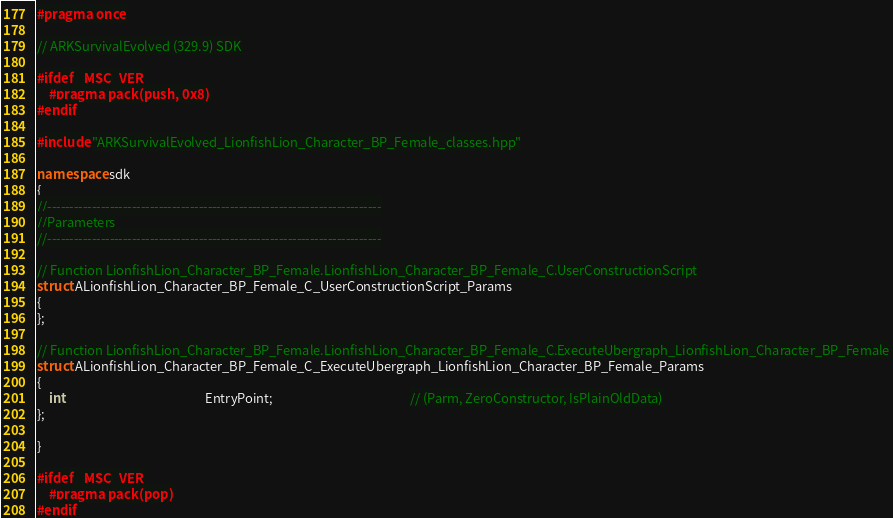Convert code to text. <code><loc_0><loc_0><loc_500><loc_500><_C++_>#pragma once

// ARKSurvivalEvolved (329.9) SDK

#ifdef _MSC_VER
	#pragma pack(push, 0x8)
#endif

#include "ARKSurvivalEvolved_LionfishLion_Character_BP_Female_classes.hpp"

namespace sdk
{
//---------------------------------------------------------------------------
//Parameters
//---------------------------------------------------------------------------

// Function LionfishLion_Character_BP_Female.LionfishLion_Character_BP_Female_C.UserConstructionScript
struct ALionfishLion_Character_BP_Female_C_UserConstructionScript_Params
{
};

// Function LionfishLion_Character_BP_Female.LionfishLion_Character_BP_Female_C.ExecuteUbergraph_LionfishLion_Character_BP_Female
struct ALionfishLion_Character_BP_Female_C_ExecuteUbergraph_LionfishLion_Character_BP_Female_Params
{
	int                                                EntryPoint;                                               // (Parm, ZeroConstructor, IsPlainOldData)
};

}

#ifdef _MSC_VER
	#pragma pack(pop)
#endif
</code> 